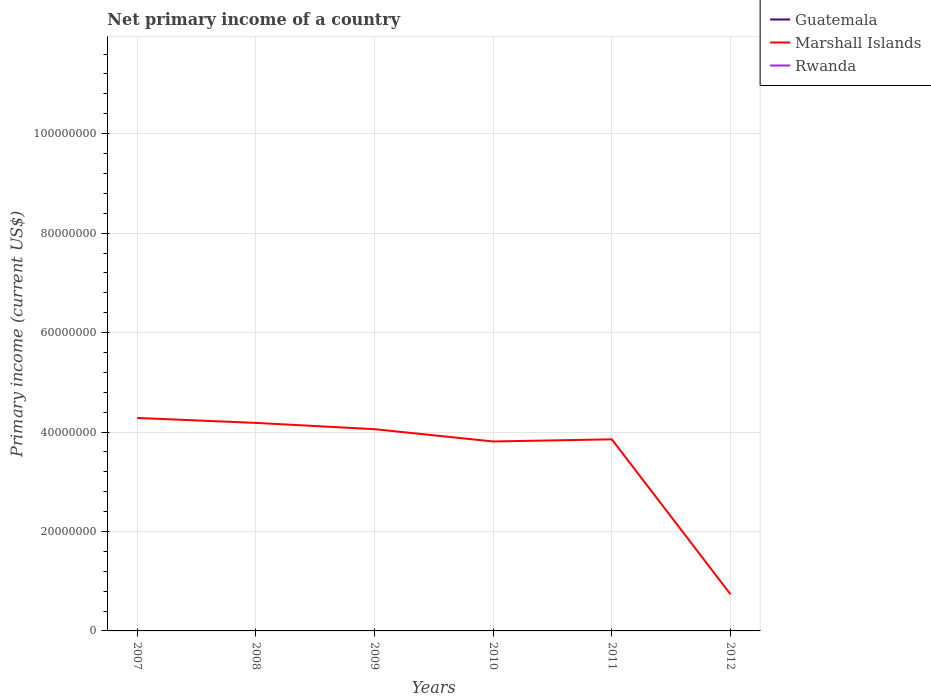Across all years, what is the maximum primary income in Marshall Islands?
Provide a short and direct response. 7.37e+06. What is the total primary income in Marshall Islands in the graph?
Give a very brief answer. 2.26e+06. What is the difference between the highest and the lowest primary income in Marshall Islands?
Offer a very short reply. 5. Is the primary income in Guatemala strictly greater than the primary income in Marshall Islands over the years?
Provide a short and direct response. Yes. How many lines are there?
Make the answer very short. 1. What is the difference between two consecutive major ticks on the Y-axis?
Your answer should be very brief. 2.00e+07. Are the values on the major ticks of Y-axis written in scientific E-notation?
Your answer should be very brief. No. Does the graph contain any zero values?
Provide a short and direct response. Yes. Does the graph contain grids?
Offer a terse response. Yes. How are the legend labels stacked?
Your answer should be very brief. Vertical. What is the title of the graph?
Offer a terse response. Net primary income of a country. What is the label or title of the X-axis?
Your answer should be compact. Years. What is the label or title of the Y-axis?
Provide a short and direct response. Primary income (current US$). What is the Primary income (current US$) in Guatemala in 2007?
Your response must be concise. 0. What is the Primary income (current US$) in Marshall Islands in 2007?
Ensure brevity in your answer.  4.28e+07. What is the Primary income (current US$) in Guatemala in 2008?
Keep it short and to the point. 0. What is the Primary income (current US$) of Marshall Islands in 2008?
Offer a very short reply. 4.18e+07. What is the Primary income (current US$) of Rwanda in 2008?
Provide a succinct answer. 0. What is the Primary income (current US$) of Marshall Islands in 2009?
Keep it short and to the point. 4.06e+07. What is the Primary income (current US$) in Rwanda in 2009?
Keep it short and to the point. 0. What is the Primary income (current US$) of Marshall Islands in 2010?
Your answer should be compact. 3.81e+07. What is the Primary income (current US$) in Guatemala in 2011?
Offer a terse response. 0. What is the Primary income (current US$) of Marshall Islands in 2011?
Provide a short and direct response. 3.85e+07. What is the Primary income (current US$) of Rwanda in 2011?
Your answer should be very brief. 0. What is the Primary income (current US$) of Guatemala in 2012?
Ensure brevity in your answer.  0. What is the Primary income (current US$) in Marshall Islands in 2012?
Your answer should be very brief. 7.37e+06. Across all years, what is the maximum Primary income (current US$) in Marshall Islands?
Provide a short and direct response. 4.28e+07. Across all years, what is the minimum Primary income (current US$) of Marshall Islands?
Offer a very short reply. 7.37e+06. What is the total Primary income (current US$) in Marshall Islands in the graph?
Your answer should be compact. 2.09e+08. What is the difference between the Primary income (current US$) in Marshall Islands in 2007 and that in 2008?
Make the answer very short. 9.94e+05. What is the difference between the Primary income (current US$) in Marshall Islands in 2007 and that in 2009?
Provide a succinct answer. 2.26e+06. What is the difference between the Primary income (current US$) of Marshall Islands in 2007 and that in 2010?
Keep it short and to the point. 4.73e+06. What is the difference between the Primary income (current US$) in Marshall Islands in 2007 and that in 2011?
Your answer should be very brief. 4.30e+06. What is the difference between the Primary income (current US$) in Marshall Islands in 2007 and that in 2012?
Give a very brief answer. 3.55e+07. What is the difference between the Primary income (current US$) of Marshall Islands in 2008 and that in 2009?
Ensure brevity in your answer.  1.26e+06. What is the difference between the Primary income (current US$) in Marshall Islands in 2008 and that in 2010?
Keep it short and to the point. 3.74e+06. What is the difference between the Primary income (current US$) of Marshall Islands in 2008 and that in 2011?
Your response must be concise. 3.31e+06. What is the difference between the Primary income (current US$) of Marshall Islands in 2008 and that in 2012?
Provide a succinct answer. 3.45e+07. What is the difference between the Primary income (current US$) of Marshall Islands in 2009 and that in 2010?
Your response must be concise. 2.47e+06. What is the difference between the Primary income (current US$) of Marshall Islands in 2009 and that in 2011?
Provide a succinct answer. 2.04e+06. What is the difference between the Primary income (current US$) in Marshall Islands in 2009 and that in 2012?
Provide a succinct answer. 3.32e+07. What is the difference between the Primary income (current US$) in Marshall Islands in 2010 and that in 2011?
Provide a short and direct response. -4.31e+05. What is the difference between the Primary income (current US$) in Marshall Islands in 2010 and that in 2012?
Your answer should be compact. 3.07e+07. What is the difference between the Primary income (current US$) of Marshall Islands in 2011 and that in 2012?
Provide a short and direct response. 3.12e+07. What is the average Primary income (current US$) in Guatemala per year?
Make the answer very short. 0. What is the average Primary income (current US$) of Marshall Islands per year?
Make the answer very short. 3.49e+07. What is the ratio of the Primary income (current US$) in Marshall Islands in 2007 to that in 2008?
Your answer should be compact. 1.02. What is the ratio of the Primary income (current US$) of Marshall Islands in 2007 to that in 2009?
Offer a terse response. 1.06. What is the ratio of the Primary income (current US$) in Marshall Islands in 2007 to that in 2010?
Offer a very short reply. 1.12. What is the ratio of the Primary income (current US$) in Marshall Islands in 2007 to that in 2011?
Your response must be concise. 1.11. What is the ratio of the Primary income (current US$) in Marshall Islands in 2007 to that in 2012?
Your response must be concise. 5.81. What is the ratio of the Primary income (current US$) in Marshall Islands in 2008 to that in 2009?
Ensure brevity in your answer.  1.03. What is the ratio of the Primary income (current US$) in Marshall Islands in 2008 to that in 2010?
Give a very brief answer. 1.1. What is the ratio of the Primary income (current US$) in Marshall Islands in 2008 to that in 2011?
Your answer should be compact. 1.09. What is the ratio of the Primary income (current US$) of Marshall Islands in 2008 to that in 2012?
Your answer should be compact. 5.67. What is the ratio of the Primary income (current US$) of Marshall Islands in 2009 to that in 2010?
Ensure brevity in your answer.  1.06. What is the ratio of the Primary income (current US$) in Marshall Islands in 2009 to that in 2011?
Offer a very short reply. 1.05. What is the ratio of the Primary income (current US$) in Marshall Islands in 2009 to that in 2012?
Make the answer very short. 5.5. What is the ratio of the Primary income (current US$) of Marshall Islands in 2010 to that in 2011?
Make the answer very short. 0.99. What is the ratio of the Primary income (current US$) in Marshall Islands in 2010 to that in 2012?
Your answer should be very brief. 5.17. What is the ratio of the Primary income (current US$) of Marshall Islands in 2011 to that in 2012?
Offer a very short reply. 5.23. What is the difference between the highest and the second highest Primary income (current US$) of Marshall Islands?
Your response must be concise. 9.94e+05. What is the difference between the highest and the lowest Primary income (current US$) in Marshall Islands?
Offer a very short reply. 3.55e+07. 